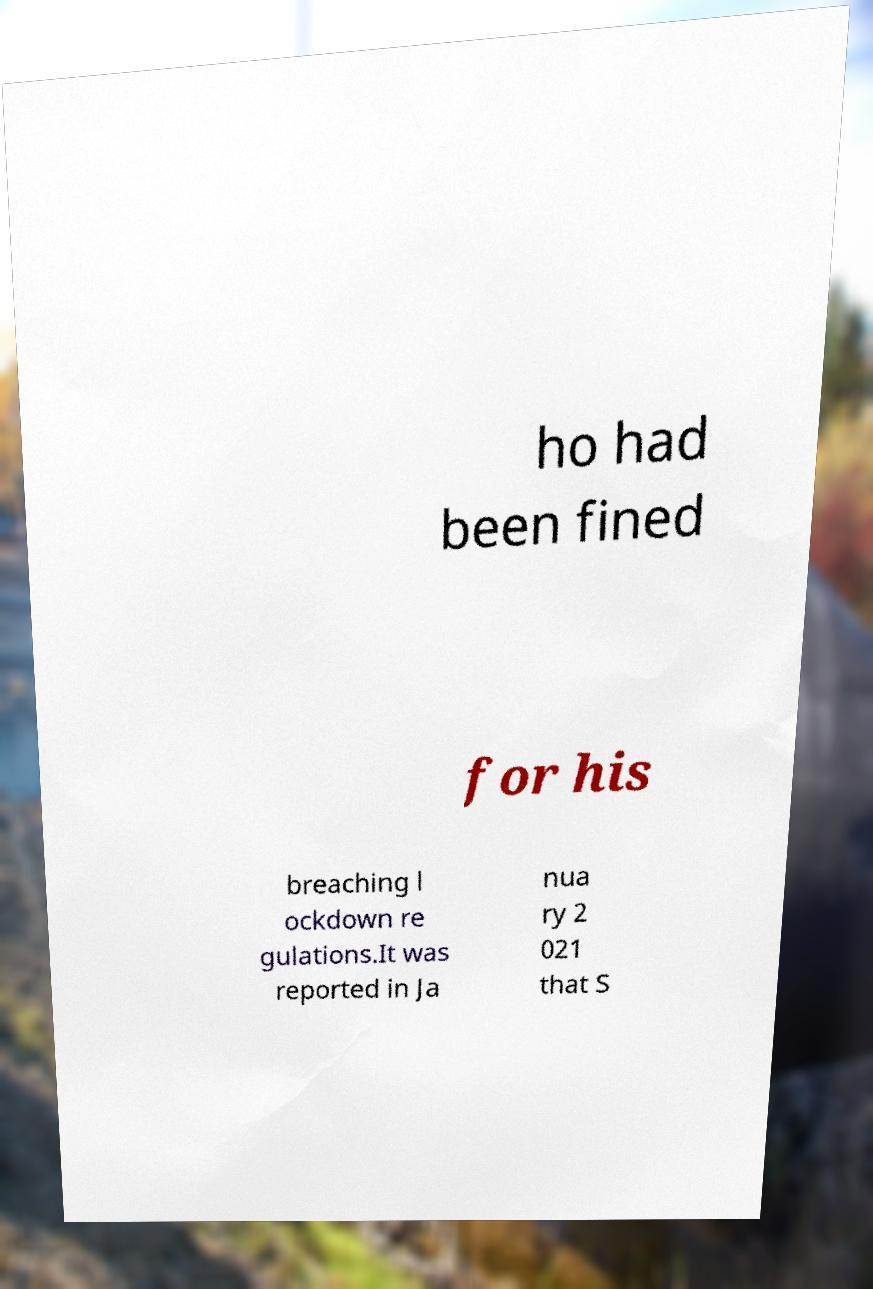Could you extract and type out the text from this image? ho had been fined for his breaching l ockdown re gulations.It was reported in Ja nua ry 2 021 that S 